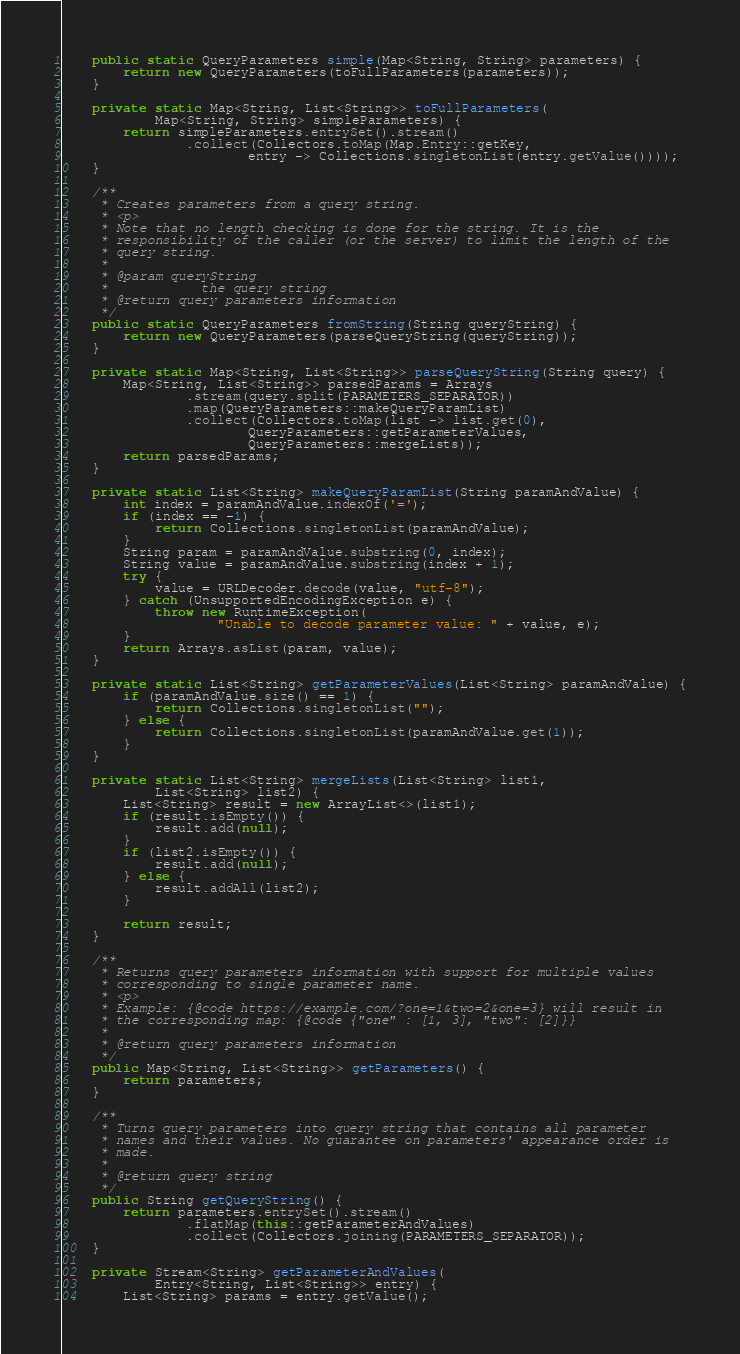<code> <loc_0><loc_0><loc_500><loc_500><_Java_>    public static QueryParameters simple(Map<String, String> parameters) {
        return new QueryParameters(toFullParameters(parameters));
    }

    private static Map<String, List<String>> toFullParameters(
            Map<String, String> simpleParameters) {
        return simpleParameters.entrySet().stream()
                .collect(Collectors.toMap(Map.Entry::getKey,
                        entry -> Collections.singletonList(entry.getValue())));
    }

    /**
     * Creates parameters from a query string.
     * <p>
     * Note that no length checking is done for the string. It is the
     * responsibility of the caller (or the server) to limit the length of the
     * query string.
     *
     * @param queryString
     *            the query string
     * @return query parameters information
     */
    public static QueryParameters fromString(String queryString) {
        return new QueryParameters(parseQueryString(queryString));
    }

    private static Map<String, List<String>> parseQueryString(String query) {
        Map<String, List<String>> parsedParams = Arrays
                .stream(query.split(PARAMETERS_SEPARATOR))
                .map(QueryParameters::makeQueryParamList)
                .collect(Collectors.toMap(list -> list.get(0),
                        QueryParameters::getParameterValues,
                        QueryParameters::mergeLists));
        return parsedParams;
    }

    private static List<String> makeQueryParamList(String paramAndValue) {
        int index = paramAndValue.indexOf('=');
        if (index == -1) {
            return Collections.singletonList(paramAndValue);
        }
        String param = paramAndValue.substring(0, index);
        String value = paramAndValue.substring(index + 1);
        try {
            value = URLDecoder.decode(value, "utf-8");
        } catch (UnsupportedEncodingException e) {
            throw new RuntimeException(
                    "Unable to decode parameter value: " + value, e);
        }
        return Arrays.asList(param, value);
    }

    private static List<String> getParameterValues(List<String> paramAndValue) {
        if (paramAndValue.size() == 1) {
            return Collections.singletonList("");
        } else {
            return Collections.singletonList(paramAndValue.get(1));
        }
    }

    private static List<String> mergeLists(List<String> list1,
            List<String> list2) {
        List<String> result = new ArrayList<>(list1);
        if (result.isEmpty()) {
            result.add(null);
        }
        if (list2.isEmpty()) {
            result.add(null);
        } else {
            result.addAll(list2);
        }

        return result;
    }

    /**
     * Returns query parameters information with support for multiple values
     * corresponding to single parameter name.
     * <p>
     * Example: {@code https://example.com/?one=1&two=2&one=3} will result in
     * the corresponding map: {@code {"one" : [1, 3], "two": [2]}}
     *
     * @return query parameters information
     */
    public Map<String, List<String>> getParameters() {
        return parameters;
    }

    /**
     * Turns query parameters into query string that contains all parameter
     * names and their values. No guarantee on parameters' appearance order is
     * made.
     *
     * @return query string
     */
    public String getQueryString() {
        return parameters.entrySet().stream()
                .flatMap(this::getParameterAndValues)
                .collect(Collectors.joining(PARAMETERS_SEPARATOR));
    }

    private Stream<String> getParameterAndValues(
            Entry<String, List<String>> entry) {
        List<String> params = entry.getValue();</code> 